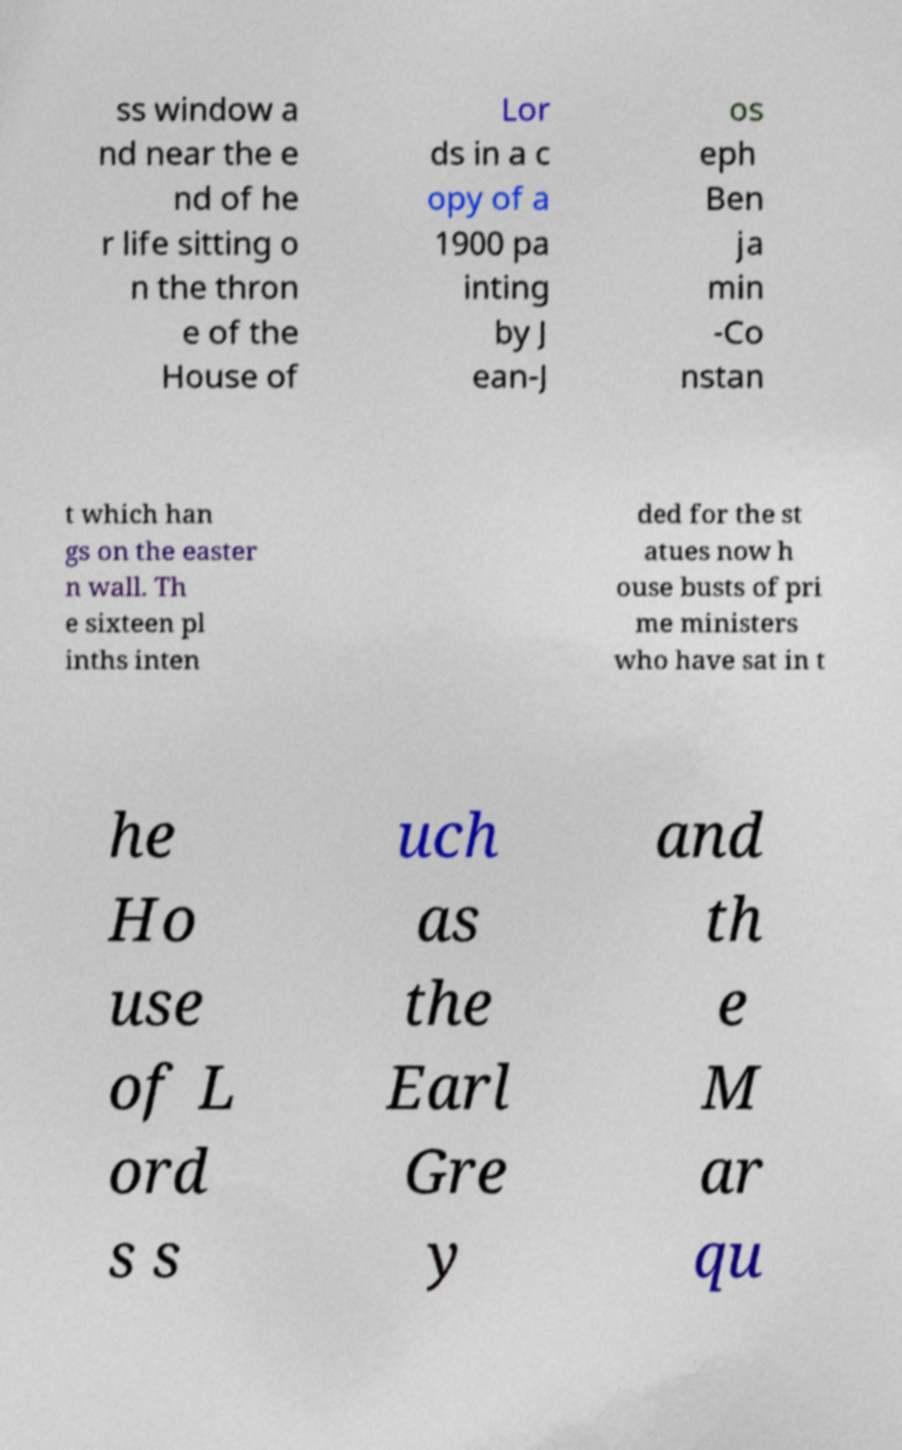I need the written content from this picture converted into text. Can you do that? ss window a nd near the e nd of he r life sitting o n the thron e of the House of Lor ds in a c opy of a 1900 pa inting by J ean-J os eph Ben ja min -Co nstan t which han gs on the easter n wall. Th e sixteen pl inths inten ded for the st atues now h ouse busts of pri me ministers who have sat in t he Ho use of L ord s s uch as the Earl Gre y and th e M ar qu 